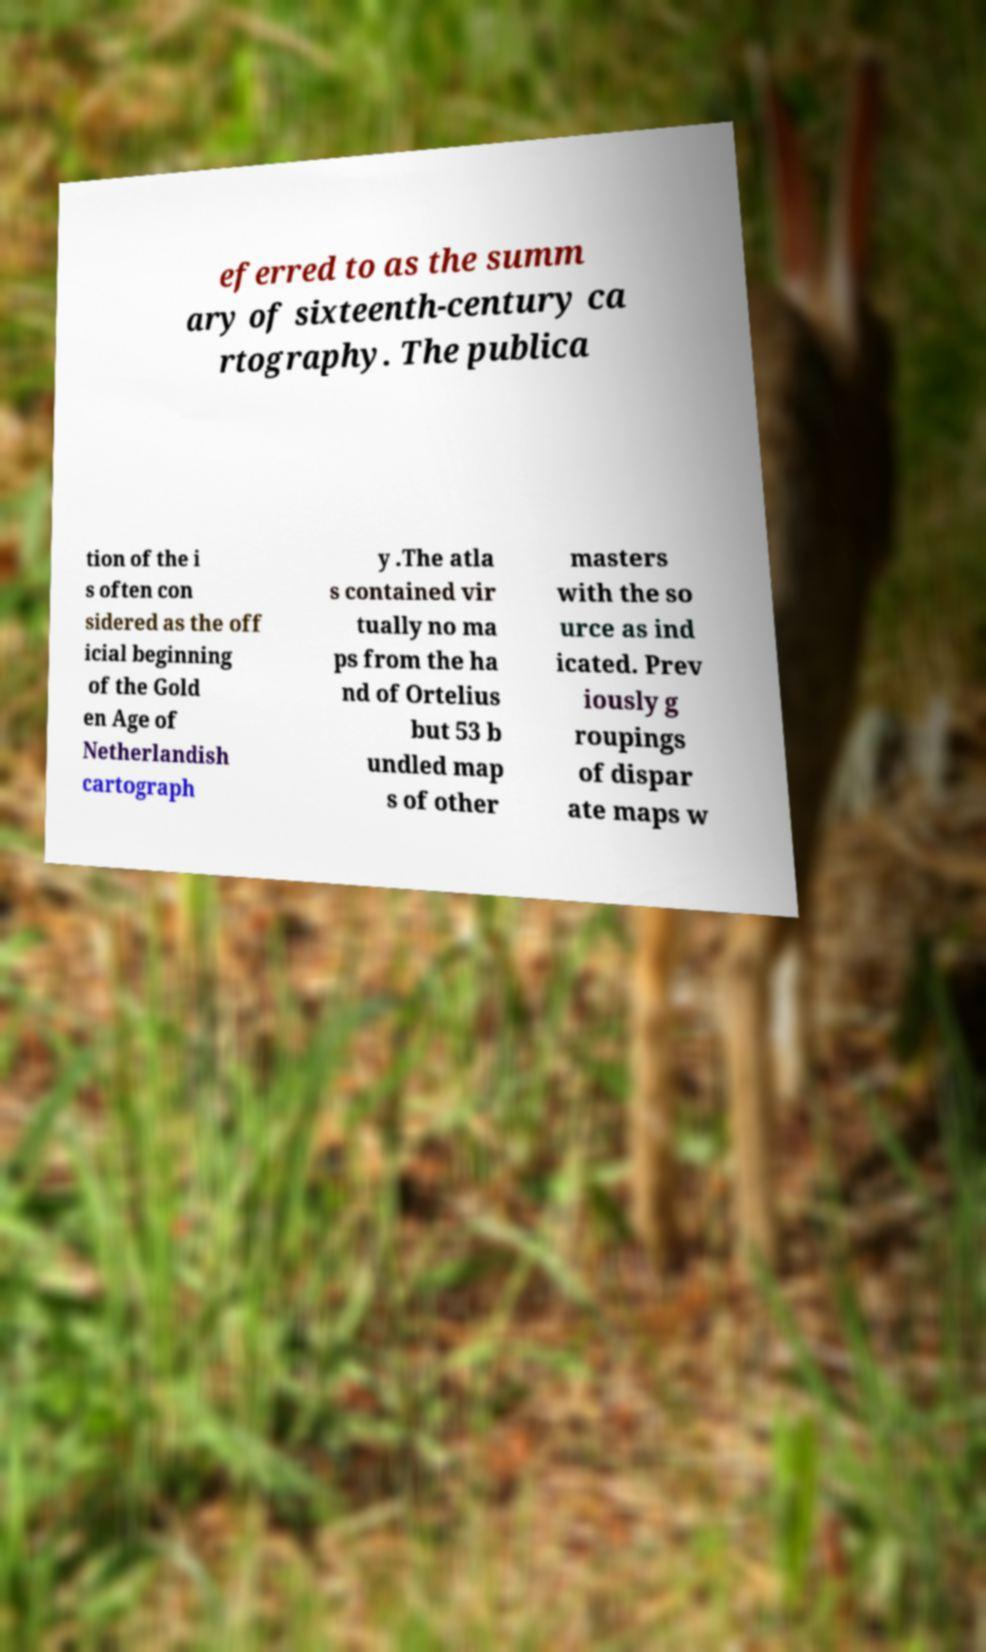Could you assist in decoding the text presented in this image and type it out clearly? eferred to as the summ ary of sixteenth-century ca rtography. The publica tion of the i s often con sidered as the off icial beginning of the Gold en Age of Netherlandish cartograph y .The atla s contained vir tually no ma ps from the ha nd of Ortelius but 53 b undled map s of other masters with the so urce as ind icated. Prev iously g roupings of dispar ate maps w 